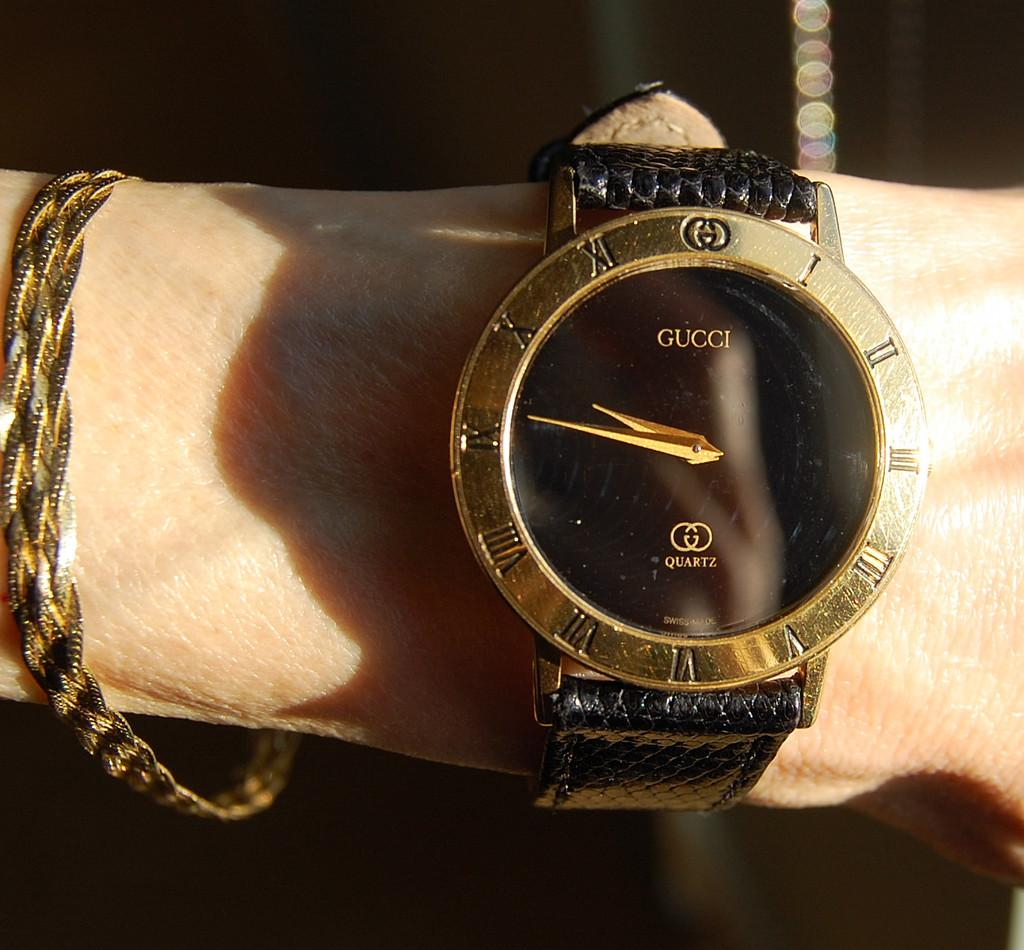<image>
Create a compact narrative representing the image presented. A black and gold watch that says Gucci on the watch face. 